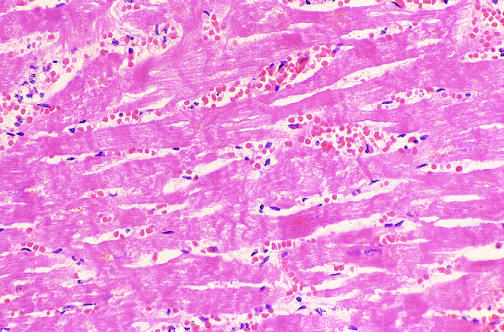re laceration of the scalp seen microscopically?
Answer the question using a single word or phrase. No 